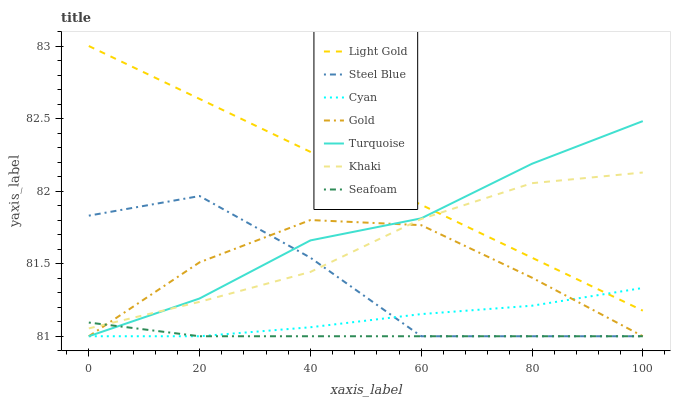Does Seafoam have the minimum area under the curve?
Answer yes or no. Yes. Does Light Gold have the maximum area under the curve?
Answer yes or no. Yes. Does Khaki have the minimum area under the curve?
Answer yes or no. No. Does Khaki have the maximum area under the curve?
Answer yes or no. No. Is Light Gold the smoothest?
Answer yes or no. Yes. Is Steel Blue the roughest?
Answer yes or no. Yes. Is Khaki the smoothest?
Answer yes or no. No. Is Khaki the roughest?
Answer yes or no. No. Does Khaki have the lowest value?
Answer yes or no. No. Does Light Gold have the highest value?
Answer yes or no. Yes. Does Khaki have the highest value?
Answer yes or no. No. Is Seafoam less than Light Gold?
Answer yes or no. Yes. Is Light Gold greater than Seafoam?
Answer yes or no. Yes. Does Steel Blue intersect Seafoam?
Answer yes or no. Yes. Is Steel Blue less than Seafoam?
Answer yes or no. No. Is Steel Blue greater than Seafoam?
Answer yes or no. No. Does Seafoam intersect Light Gold?
Answer yes or no. No. 